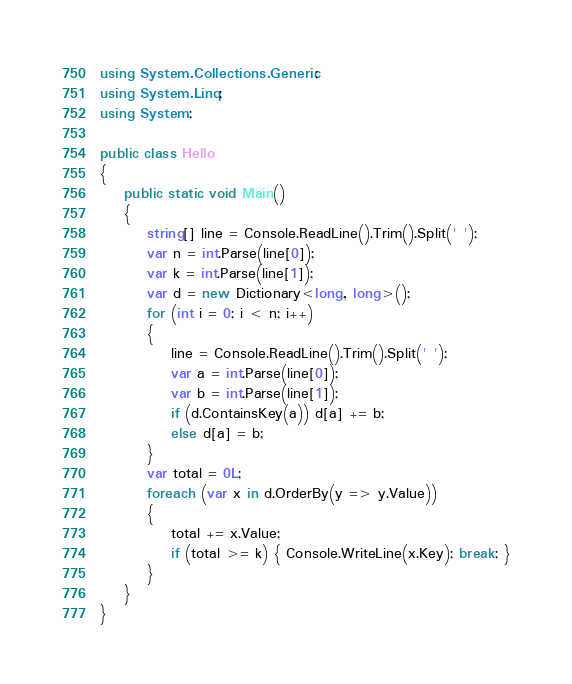Convert code to text. <code><loc_0><loc_0><loc_500><loc_500><_C#_>using System.Collections.Generic;
using System.Linq;
using System;

public class Hello
{
    public static void Main()
    {
        string[] line = Console.ReadLine().Trim().Split(' ');
        var n = int.Parse(line[0]);
        var k = int.Parse(line[1]);
        var d = new Dictionary<long, long>();
        for (int i = 0; i < n; i++)
        {
            line = Console.ReadLine().Trim().Split(' ');
            var a = int.Parse(line[0]);
            var b = int.Parse(line[1]);
            if (d.ContainsKey(a)) d[a] += b;
            else d[a] = b;
        }
        var total = 0L;
        foreach (var x in d.OrderBy(y => y.Value))
        {
            total += x.Value;
            if (total >= k) { Console.WriteLine(x.Key); break; }
        }
    }
}</code> 